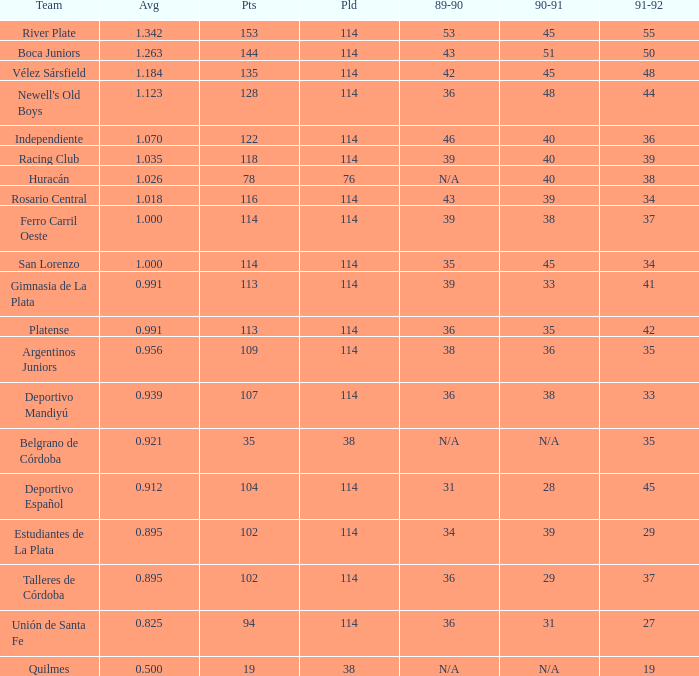How much 1991-1992 has a Team of gimnasia de la plata, and more than 113 points? 0.0. 